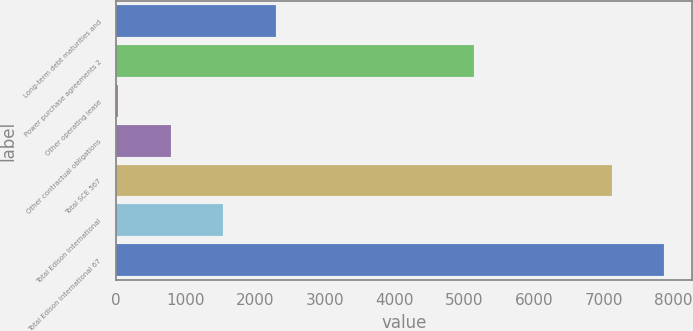Convert chart to OTSL. <chart><loc_0><loc_0><loc_500><loc_500><bar_chart><fcel>Long-term debt maturities and<fcel>Power purchase agreements 2<fcel>Other operating lease<fcel>Other contractual obligations<fcel>Total SCE 567<fcel>Total Edison International<fcel>Total Edison International 67<nl><fcel>2296.4<fcel>5144<fcel>35<fcel>788.8<fcel>7114<fcel>1542.6<fcel>7867.8<nl></chart> 